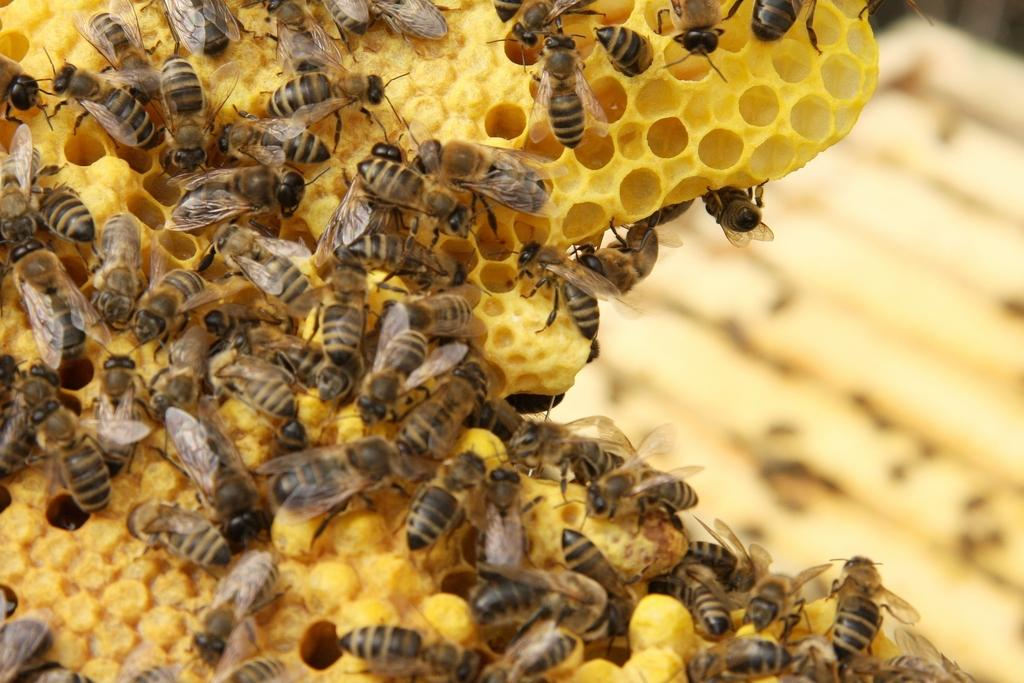What insects are present in the image? There are many honey bees in the image. What structure is associated with the honey bees in the image? There is a beehive in the image. What color is the beehive? The beehive is yellow in color. Can you describe the background of the image? The background of the image is blurred. How many fingers can be seen reaching into the beehive in the image? There are no fingers visible in the image; it only features honey bees and a beehive. 